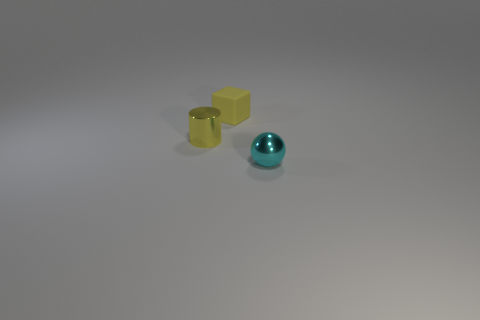Add 2 big cylinders. How many objects exist? 5 Subtract all cubes. How many objects are left? 2 Subtract all red cylinders. How many red cubes are left? 0 Subtract all brown matte cylinders. Subtract all metal spheres. How many objects are left? 2 Add 2 cyan shiny spheres. How many cyan shiny spheres are left? 3 Add 2 blue matte cubes. How many blue matte cubes exist? 2 Subtract 1 cyan balls. How many objects are left? 2 